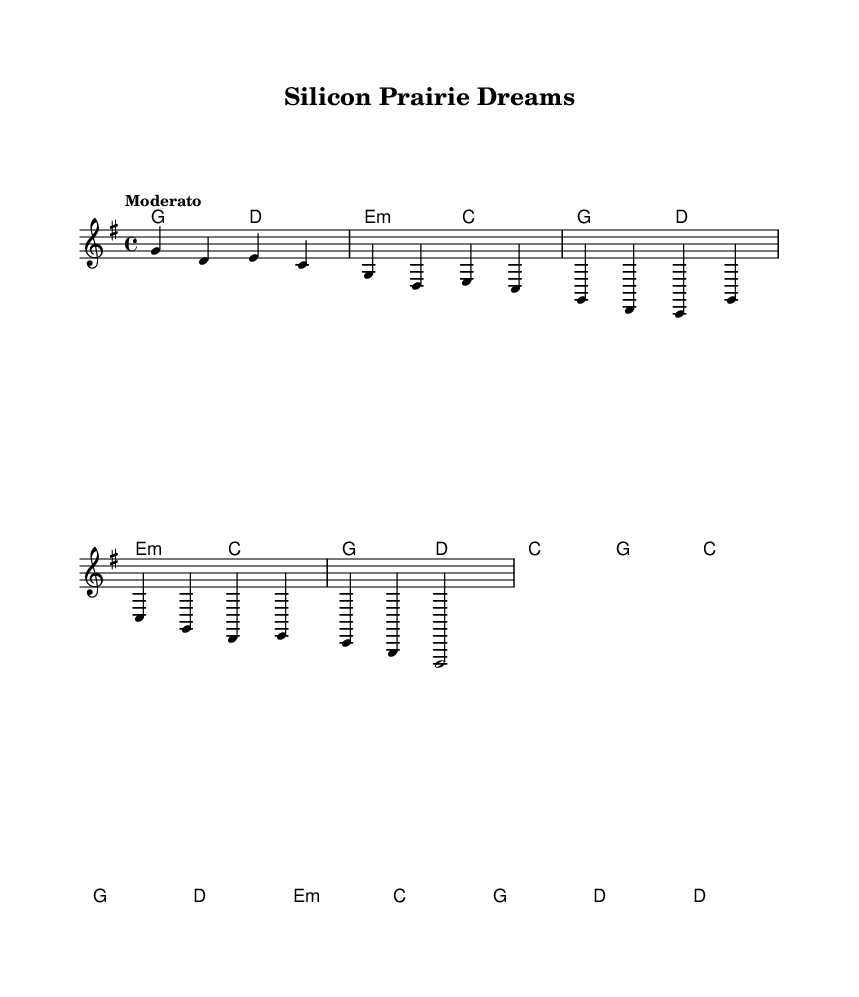What is the title of the piece? The title of the piece is located in the header section of the sheet music. It is stated as "Silicon Prairie Dreams".
Answer: Silicon Prairie Dreams What is the key signature of this music? The key signature is indicated in the global section of the sheet music. Here it shows "g \major", which means the piece is in G major.
Answer: G major What is the time signature of this music? The time signature is also provided in the global section and it reads "4/4", which is a common meter indicating four beats per measure.
Answer: 4/4 What is the tempo marking of this music? The tempo marking is specified in the global section as "Moderato", indicating a moderate speed for the piece.
Answer: Moderato How many verses are indicated in the lyrics? The provided lyrics section includes only one verse indicated, labeled as “1.”. This suggests there is one stanza of verse before the chorus.
Answer: 1 What is the name of the chorus in the lyrics? The name of the chorus is indicated with the word "Chorus" in the lyrics section, which designates the subsequent lines as the chorus of the song.
Answer: Chorus Which chord is used in the intro section? The chord sequence for the intro is mentioned in the harmonies section and it begins with "g" followed by "d", indicating that G is the chord used at the start.
Answer: g 